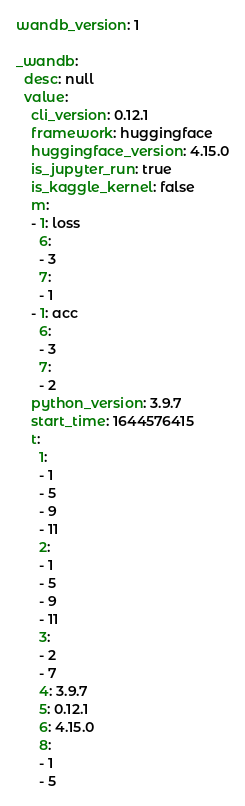Convert code to text. <code><loc_0><loc_0><loc_500><loc_500><_YAML_>wandb_version: 1

_wandb:
  desc: null
  value:
    cli_version: 0.12.1
    framework: huggingface
    huggingface_version: 4.15.0
    is_jupyter_run: true
    is_kaggle_kernel: false
    m:
    - 1: loss
      6:
      - 3
      7:
      - 1
    - 1: acc
      6:
      - 3
      7:
      - 2
    python_version: 3.9.7
    start_time: 1644576415
    t:
      1:
      - 1
      - 5
      - 9
      - 11
      2:
      - 1
      - 5
      - 9
      - 11
      3:
      - 2
      - 7
      4: 3.9.7
      5: 0.12.1
      6: 4.15.0
      8:
      - 1
      - 5
</code> 